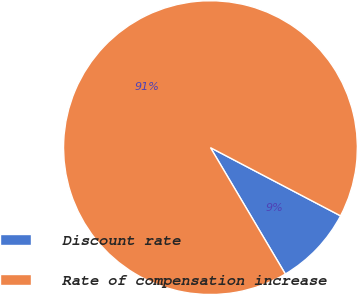Convert chart. <chart><loc_0><loc_0><loc_500><loc_500><pie_chart><fcel>Discount rate<fcel>Rate of compensation increase<nl><fcel>8.8%<fcel>91.2%<nl></chart> 